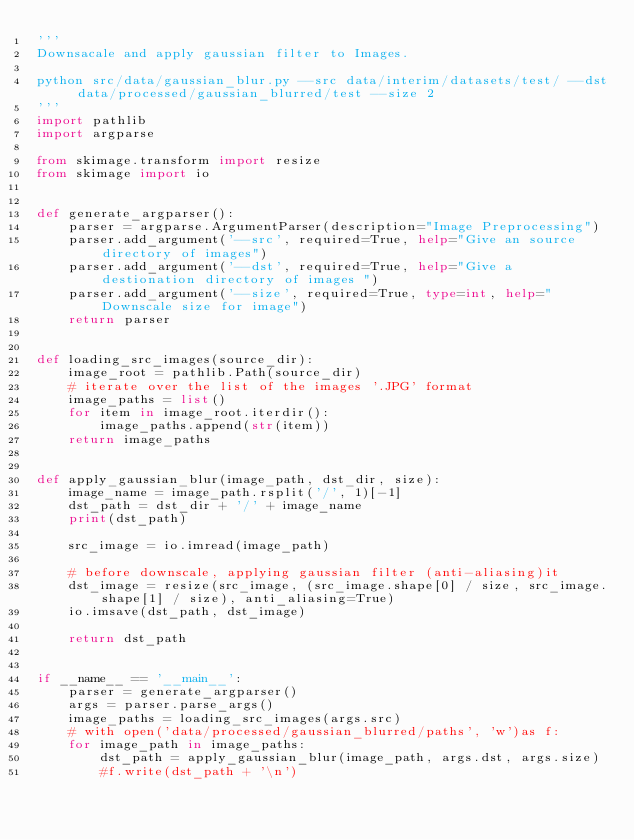Convert code to text. <code><loc_0><loc_0><loc_500><loc_500><_Python_>'''
Downsacale and apply gaussian filter to Images.

python src/data/gaussian_blur.py --src data/interim/datasets/test/ --dst data/processed/gaussian_blurred/test --size 2
'''
import pathlib
import argparse

from skimage.transform import resize
from skimage import io


def generate_argparser():
    parser = argparse.ArgumentParser(description="Image Preprocessing")
    parser.add_argument('--src', required=True, help="Give an source directory of images")
    parser.add_argument('--dst', required=True, help="Give a destionation directory of images ")
    parser.add_argument('--size', required=True, type=int, help="Downscale size for image")
    return parser


def loading_src_images(source_dir):
    image_root = pathlib.Path(source_dir)
    # iterate over the list of the images '.JPG' format
    image_paths = list()
    for item in image_root.iterdir():
        image_paths.append(str(item))
    return image_paths


def apply_gaussian_blur(image_path, dst_dir, size):
    image_name = image_path.rsplit('/', 1)[-1]
    dst_path = dst_dir + '/' + image_name
    print(dst_path)

    src_image = io.imread(image_path)

    # before downscale, applying gaussian filter (anti-aliasing)it
    dst_image = resize(src_image, (src_image.shape[0] / size, src_image.shape[1] / size), anti_aliasing=True)
    io.imsave(dst_path, dst_image)

    return dst_path


if __name__ == '__main__':
    parser = generate_argparser()
    args = parser.parse_args()
    image_paths = loading_src_images(args.src)
    # with open('data/processed/gaussian_blurred/paths', 'w')as f:
    for image_path in image_paths:
        dst_path = apply_gaussian_blur(image_path, args.dst, args.size)
        #f.write(dst_path + '\n')
</code> 